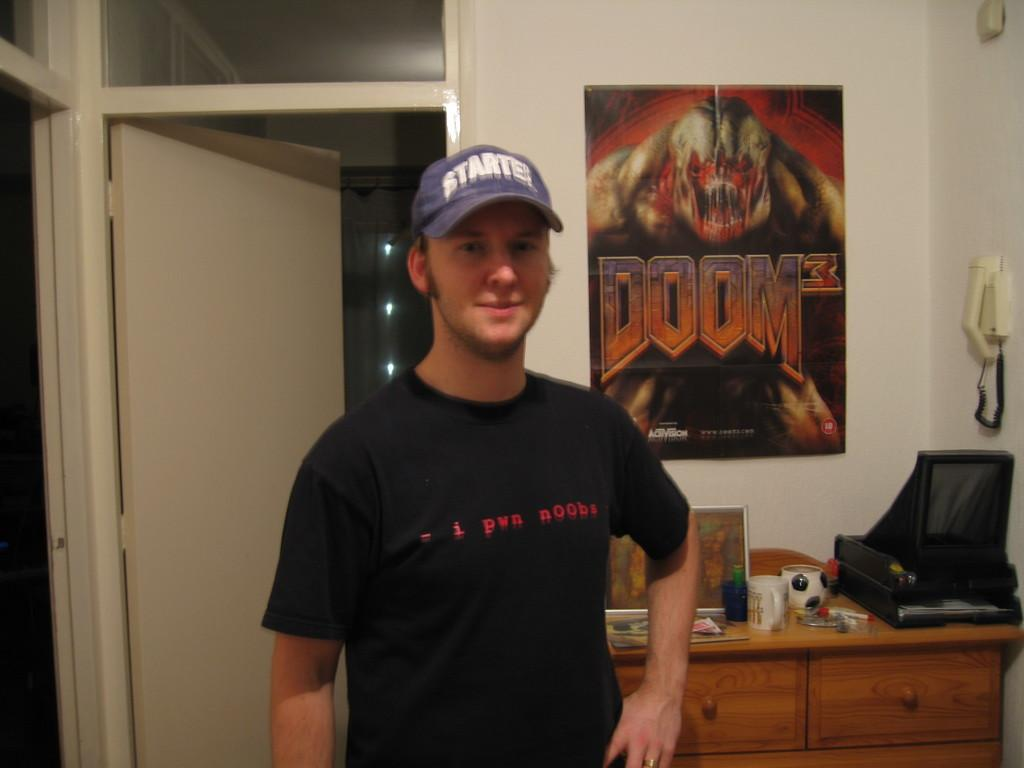<image>
Describe the image concisely. A man wearing a red shirt that reads I Pwn Noobs with a poster of Doom 3 hangin in the wall behind him. 